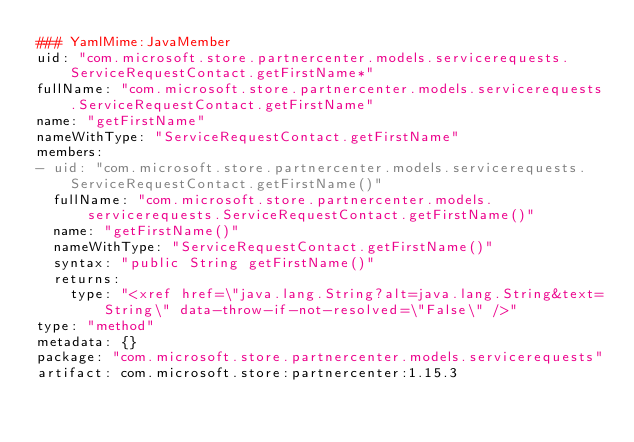Convert code to text. <code><loc_0><loc_0><loc_500><loc_500><_YAML_>### YamlMime:JavaMember
uid: "com.microsoft.store.partnercenter.models.servicerequests.ServiceRequestContact.getFirstName*"
fullName: "com.microsoft.store.partnercenter.models.servicerequests.ServiceRequestContact.getFirstName"
name: "getFirstName"
nameWithType: "ServiceRequestContact.getFirstName"
members:
- uid: "com.microsoft.store.partnercenter.models.servicerequests.ServiceRequestContact.getFirstName()"
  fullName: "com.microsoft.store.partnercenter.models.servicerequests.ServiceRequestContact.getFirstName()"
  name: "getFirstName()"
  nameWithType: "ServiceRequestContact.getFirstName()"
  syntax: "public String getFirstName()"
  returns:
    type: "<xref href=\"java.lang.String?alt=java.lang.String&text=String\" data-throw-if-not-resolved=\"False\" />"
type: "method"
metadata: {}
package: "com.microsoft.store.partnercenter.models.servicerequests"
artifact: com.microsoft.store:partnercenter:1.15.3
</code> 